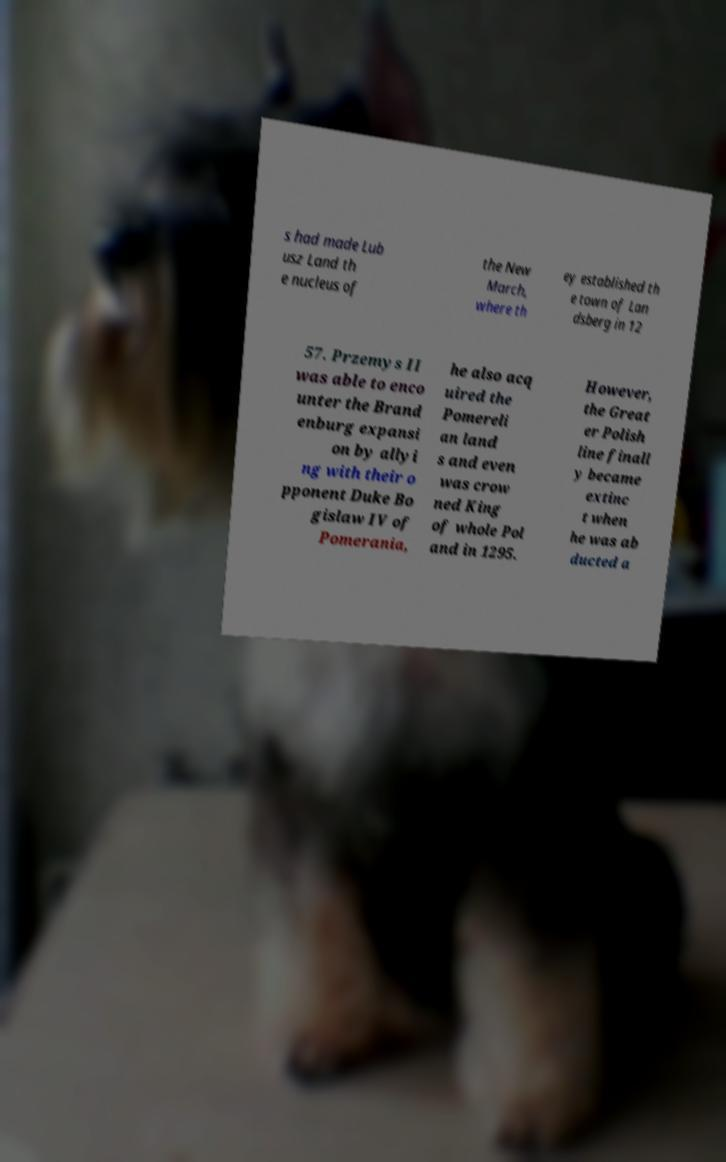For documentation purposes, I need the text within this image transcribed. Could you provide that? s had made Lub usz Land th e nucleus of the New March, where th ey established th e town of Lan dsberg in 12 57. Przemys II was able to enco unter the Brand enburg expansi on by allyi ng with their o pponent Duke Bo gislaw IV of Pomerania, he also acq uired the Pomereli an land s and even was crow ned King of whole Pol and in 1295. However, the Great er Polish line finall y became extinc t when he was ab ducted a 